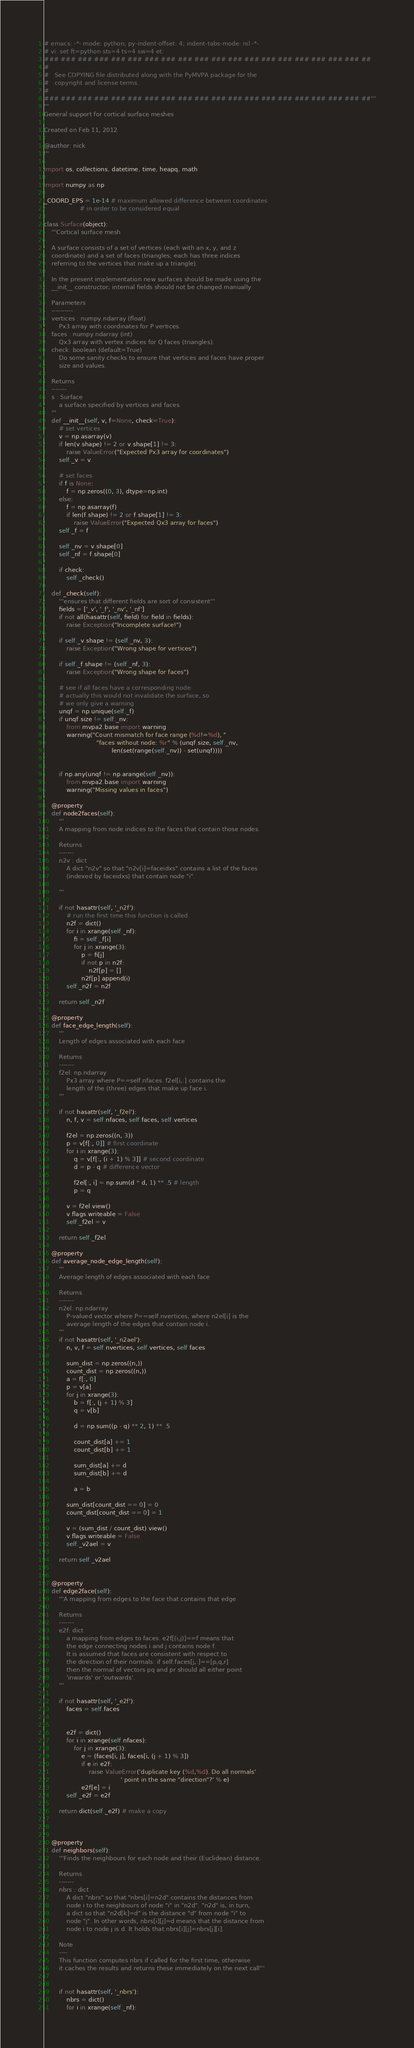<code> <loc_0><loc_0><loc_500><loc_500><_Python_># emacs: -*- mode: python; py-indent-offset: 4; indent-tabs-mode: nil -*-
# vi: set ft=python sts=4 ts=4 sw=4 et:
### ### ### ### ### ### ### ### ### ### ### ### ### ### ### ### ### ### ### ##
#
#   See COPYING file distributed along with the PyMVPA package for the
#   copyright and license terms.
#
### ### ### ### ### ### ### ### ### ### ### ### ### ### ### ### ### ### ### ##'''
'''
General support for cortical surface meshes

Created on Feb 11, 2012

@author: nick
'''

import os, collections, datetime, time, heapq, math

import numpy as np

_COORD_EPS = 1e-14 # maximum allowed difference between coordinates
                   # in order to be considered equal

class Surface(object):
    '''Cortical surface mesh

    A surface consists of a set of vertices (each with an x, y, and z
    coordinate) and a set of faces (triangles; each has three indices
    referring to the vertices that make up a triangle).

    In the present implementation new surfaces should be made using the
    __init__ constructor; internal fields should not be changed manually

    Parameters
    ----------
    vertices : numpy.ndarray (float)
        Px3 array with coordinates for P vertices.
    faces : numpy.ndarray (int)
        Qx3 array with vertex indices for Q faces (triangles).
    check: boolean (default=True)
        Do some sanity checks to ensure that vertices and faces have proper
        size and values.

    Returns
    -------
    s : Surface
        a surface specified by vertices and faces
    '''
    def __init__(self, v, f=None, check=True):
        # set vertices
        v = np.asarray(v)
        if len(v.shape) != 2 or v.shape[1] != 3:
            raise ValueError("Expected Px3 array for coordinates")
        self._v = v

        # set faces
        if f is None:
            f = np.zeros((0, 3), dtype=np.int)
        else:
            f = np.asarray(f)
            if len(f.shape) != 2 or f.shape[1] != 3:
                raise ValueError("Expected Qx3 array for faces")
        self._f = f

        self._nv = v.shape[0]
        self._nf = f.shape[0]

        if check:
            self._check()

    def _check(self):
        '''ensures that different fields are sort of consistent'''
        fields = ['_v', '_f', '_nv', '_nf']
        if not all(hasattr(self, field) for field in fields):
            raise Exception("Incomplete surface!")

        if self._v.shape != (self._nv, 3):
            raise Exception("Wrong shape for vertices")

        if self._f.shape != (self._nf, 3):
            raise Exception("Wrong shape for faces")

        # see if all faces have a corresponding node.
        # actually this would not invalidate the surface, so
        # we only give a warning
        unqf = np.unique(self._f)
        if unqf.size != self._nv:
            from mvpa2.base import warning
            warning("Count mismatch for face range (%d!=%d), "
                            "faces without node: %r" % (unqf.size, self._nv,
                                    len(set(range(self._nv)) - set(unqf))))


        if np.any(unqf != np.arange(self._nv)):
            from mvpa2.base import warning
            warning("Missing values in faces")

    @property
    def node2faces(self):
        '''
        A mapping from node indices to the faces that contain those nodes.

        Returns
        -------
        n2v : dict
            A dict "n2v" so that "n2v[i]=faceidxs" contains a list of the faces
            (indexed by faceidxs) that contain node "i".

        '''

        if not hasattr(self, '_n2f'):
            # run the first time this function is called
            n2f = dict()
            for i in xrange(self._nf):
                fi = self._f[i]
                for j in xrange(3):
                    p = fi[j]
                    if not p in n2f:
                        n2f[p] = []
                    n2f[p].append(i)
            self._n2f = n2f

        return self._n2f

    @property
    def face_edge_length(self):
        '''
        Length of edges associated with each face

        Returns
        -------
        f2el: np.ndarray
            Px3 array where P==self.nfaces. f2el[i,:] contains the
            length of the (three) edges that make up face i.
        '''

        if not hasattr(self, '_f2el'):
            n, f, v = self.nfaces, self.faces, self.vertices

            f2el = np.zeros((n, 3))
            p = v[f[:, 0]] # first coordinate
            for i in xrange(3):
                q = v[f[:, (i + 1) % 3]] # second coordinate
                d = p - q # difference vector

                f2el[:, i] = np.sum(d * d, 1) ** .5 # length
                p = q

            v = f2el.view()
            v.flags.writeable = False
            self._f2el = v

        return self._f2el

    @property
    def average_node_edge_length(self):
        '''
        Average length of edges associated with each face

        Returns
        -------
        n2el: np.ndarray
            P-valued vector where P==self.nvertices, where n2el[i] is the
            average length of the edges that contain node i.
        '''
        if not hasattr(self, '_n2ael'):
            n, v, f = self.nvertices, self.vertices, self.faces

            sum_dist = np.zeros((n,))
            count_dist = np.zeros((n,))
            a = f[:, 0]
            p = v[a]
            for j in xrange(3):
                b = f[:, (j + 1) % 3]
                q = v[b]

                d = np.sum((p - q) ** 2, 1) ** .5

                count_dist[a] += 1
                count_dist[b] += 1

                sum_dist[a] += d
                sum_dist[b] += d

                a = b

            sum_dist[count_dist == 0] = 0
            count_dist[count_dist == 0] = 1

            v = (sum_dist / count_dist).view()
            v.flags.writeable = False
            self._v2ael = v

        return self._v2ael


    @property
    def edge2face(self):
        '''A mapping from edges to the face that contains that edge

        Returns
        -------
        e2f: dict
            a mapping from edges to faces. e2f[(i,j)]==f means that
            the edge connecting nodes i and j contains node f.
            It is assumed that faces are consistent with respect to
            the direction of their normals: if self.faces[j,:]==[p,q,r]
            then the normal of vectors pq and pr should all either point
            'inwards' or 'outwards'.
        '''

        if not hasattr(self, '_e2f'):
            faces = self.faces


            e2f = dict()
            for i in xrange(self.nfaces):
                for j in xrange(3):
                    e = (faces[i, j], faces[i, (j + 1) % 3])
                    if e in e2f:
                        raise ValueError('duplicate key (%d,%d). Do all normals'
                                         ' point in the same "direction"?' % e)
                    e2f[e] = i
            self._e2f = e2f

        return dict(self._e2f) # make a copy



    @property
    def neighbors(self):
        '''Finds the neighbours for each node and their (Euclidean) distance.

        Returns
        -------
        nbrs : dict
            A dict "nbrs" so that "nbrs[i]=n2d" contains the distances from
            node i to the neighbours of node "i" in "n2d". "n2d" is, in turn,
            a dict so that "n2d[k]=d" is the distance "d" from node "i" to
            node "j". In other words, nbrs[i][j]=d means that the distance from
            node i to node j is d. It holds that nbrs[i][j]=nbrs[j][i].

        Note
        ----
        This function computes nbrs if called for the first time, otherwise
        it caches the results and returns these immediately on the next call'''


        if not hasattr(self, '_nbrs'):
            nbrs = dict()
            for i in xrange(self._nf):</code> 